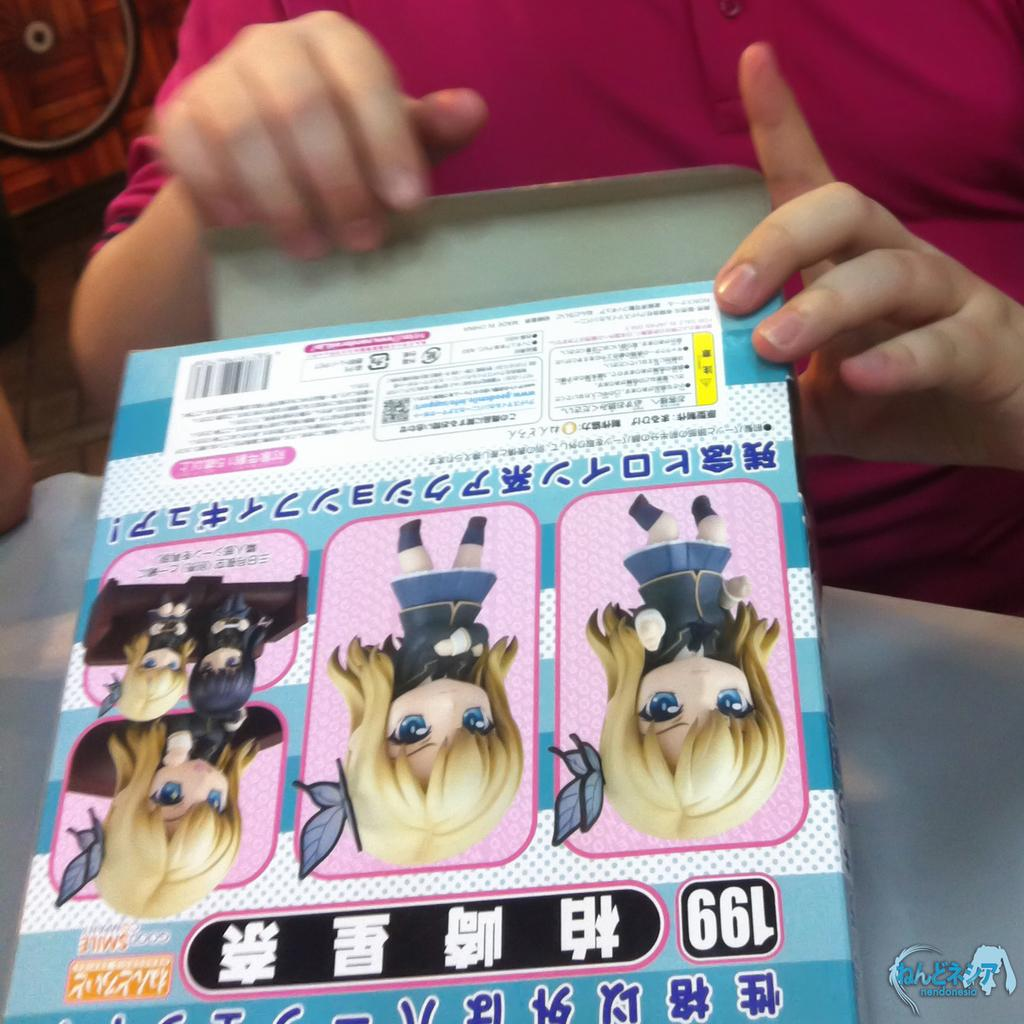Who is present in the image? There is a person in the image. What is the person doing in the image? The person is opening a toy box. What color are the person's toes in the image? There is no information about the person's toes in the image, so we cannot determine their color. 